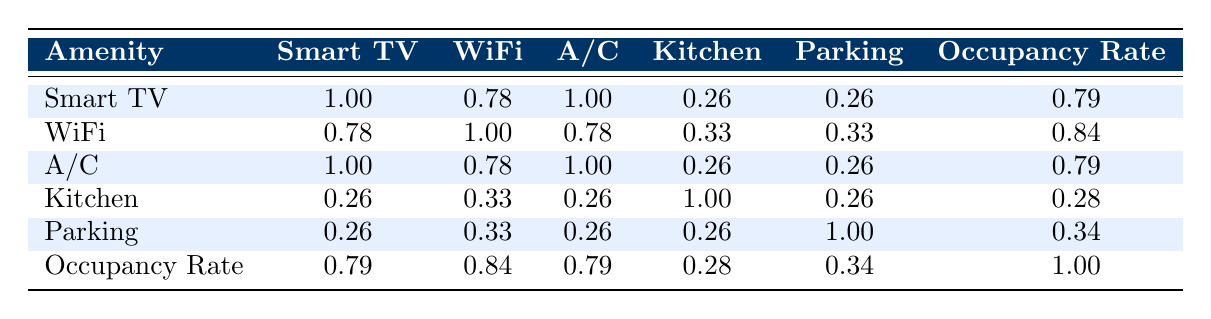What is the correlation coefficient between Smart TV availability and Occupancy Rate? The table shows a correlation coefficient of 0.79 between Smart TV and Occupancy Rate, meaning there is a strong positive relationship.
Answer: 0.79 Is having WiFi associated with a higher occupancy rate? The correlation coefficient between WiFi and Occupancy Rate is 0.84, indicating a strong positive association.
Answer: Yes What is the average occupancy rate for listings with Air Conditioning? The listings with Air Conditioning (1, 2, 4, 6, 7) have the occupancy rates of 85, 90, 95, 92, and 80, respectively. Summing these gives 85 + 90 + 95 + 92 + 80 = 442. Dividing by 5 provides an average occupancy rate of 442 / 5 = 88.4.
Answer: 88.4 Do all listings with Kitchen also have a high occupancy rate? Listings with a Kitchen (1, 2, 3, 4, 5, 6, and 7) have occupancy rates of 85, 90, 75, 95, 60, 92, and 80 respectively. Not all these rates are high, particularly 60, which is lower than 70.
Answer: No If a listing has both Smart TV and WiFi, what is the expected occupancy rate? Both Smart TV and WiFi have correlations of 0.79 and 0.84 respectively with Occupancy Rate. To estimate the expected occupancy with both amenities, we consider the most favorable existing combinations. Listings with both amenities (1, 2, 4, 6, 7) have occupancy rates of 85, 90, 95, 92, and 80, averaging at (85 + 90 + 95 + 92 + 80) / 5 = 88.4.
Answer: 88.4 